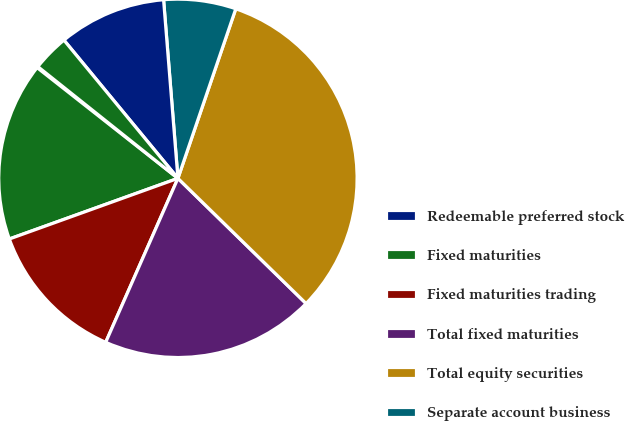<chart> <loc_0><loc_0><loc_500><loc_500><pie_chart><fcel>Redeemable preferred stock<fcel>Fixed maturities<fcel>Fixed maturities trading<fcel>Total fixed maturities<fcel>Total equity securities<fcel>Separate account business<fcel>Payable to brokers<fcel>Discontinued operations<nl><fcel>0.11%<fcel>16.1%<fcel>12.9%<fcel>19.29%<fcel>32.08%<fcel>6.51%<fcel>9.7%<fcel>3.31%<nl></chart> 